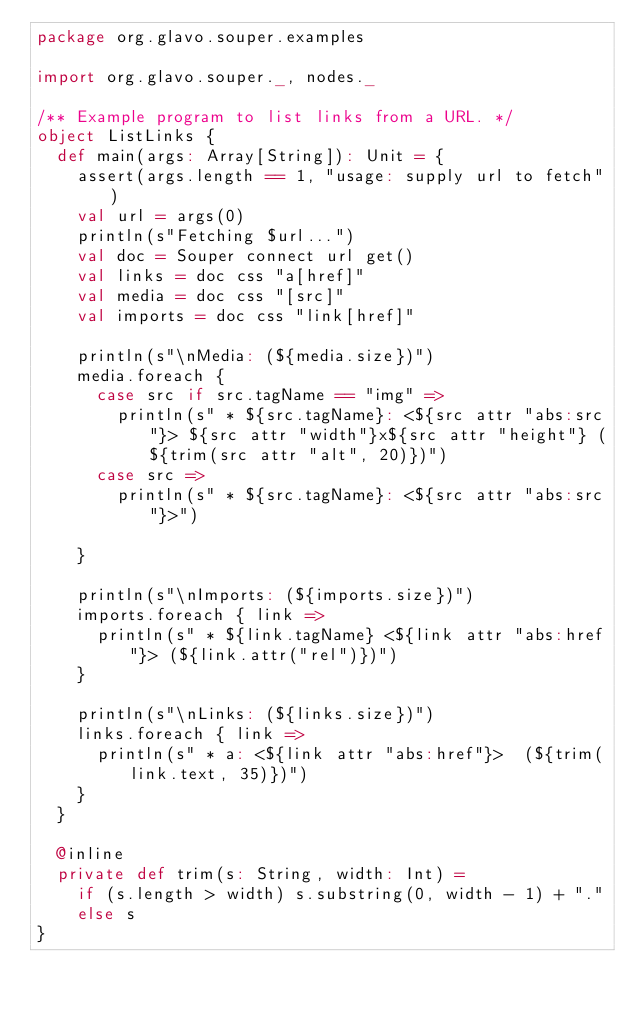Convert code to text. <code><loc_0><loc_0><loc_500><loc_500><_Scala_>package org.glavo.souper.examples

import org.glavo.souper._, nodes._

/** Example program to list links from a URL. */
object ListLinks {
  def main(args: Array[String]): Unit = {
    assert(args.length == 1, "usage: supply url to fetch")
    val url = args(0)
    println(s"Fetching $url...")
    val doc = Souper connect url get()
    val links = doc css "a[href]"
    val media = doc css "[src]"
    val imports = doc css "link[href]"

    println(s"\nMedia: (${media.size})")
    media.foreach {
      case src if src.tagName == "img" =>
        println(s" * ${src.tagName}: <${src attr "abs:src"}> ${src attr "width"}x${src attr "height"} (${trim(src attr "alt", 20)})")
      case src =>
        println(s" * ${src.tagName}: <${src attr "abs:src"}>")

    }

    println(s"\nImports: (${imports.size})")
    imports.foreach { link =>
      println(s" * ${link.tagName} <${link attr "abs:href"}> (${link.attr("rel")})")
    }

    println(s"\nLinks: (${links.size})")
    links.foreach { link =>
      println(s" * a: <${link attr "abs:href"}>  (${trim(link.text, 35)})")
    }
  }

  @inline
  private def trim(s: String, width: Int) =
    if (s.length > width) s.substring(0, width - 1) + "."
    else s
}
</code> 